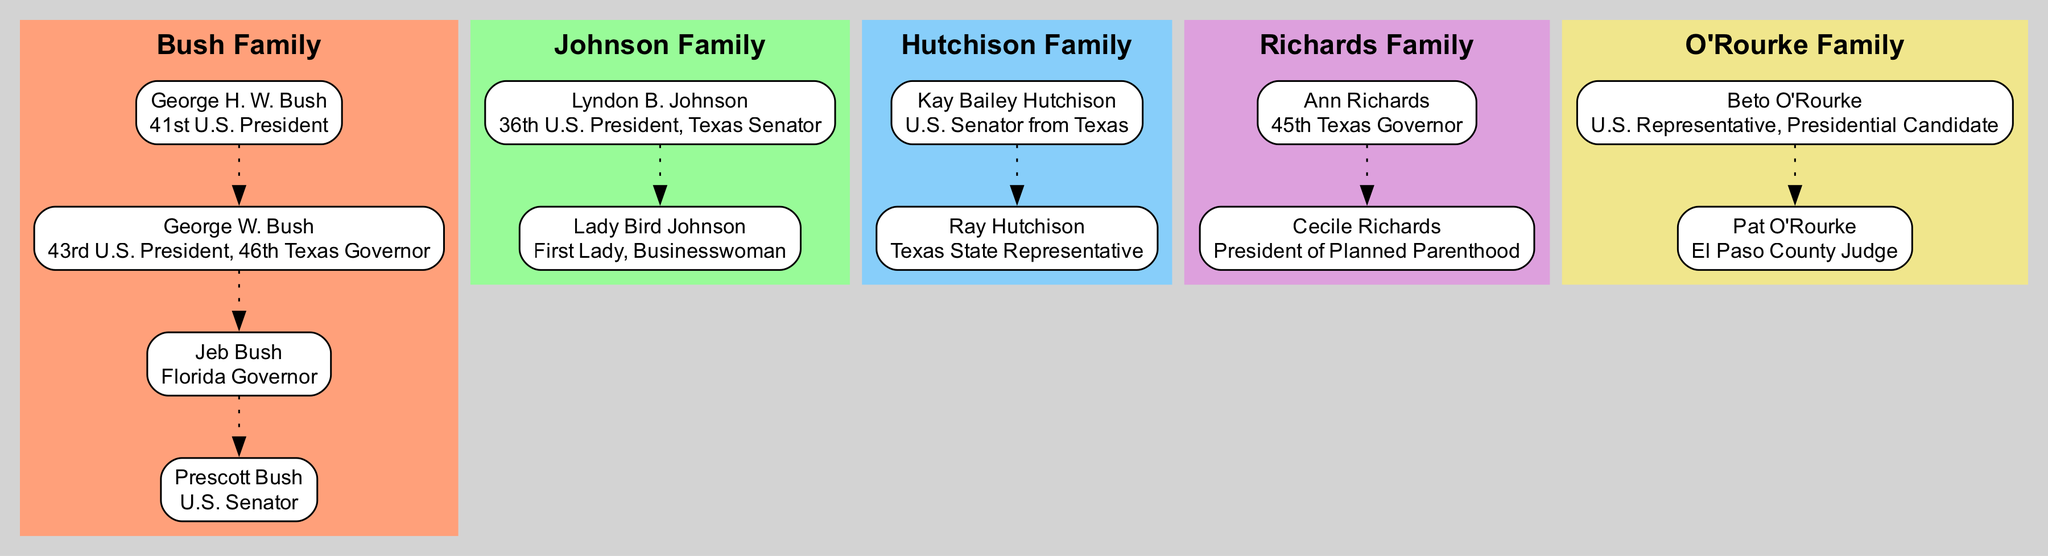What family does George W. Bush belong to? George W. Bush is listed under the "Bush Family" in the diagram. Each family is labeled with their respective notable members, and George W. Bush is clearly shown as a member of this family.
Answer: Bush Family How many family members are in the Johnson Family? The Johnson Family contains two notable members: Lyndon B. Johnson and Lady Bird Johnson. This can be found by counting the nodes connected under the "Johnson Family" label.
Answer: 2 Who is the U.S. Senator from Texas in the Hutchison Family? Kay Bailey Hutchison is identified as the U.S. Senator from Texas in the Hutchison Family section of the diagram. The role is clearly stated next to her name, connecting her directly to the family.
Answer: Kay Bailey Hutchison Which political position does Cecile Richards hold? Cecile Richards is noted as the President of Planned Parenthood. This information is directly displayed under her name in the "Richards Family" section of the diagram.
Answer: President of Planned Parenthood Which family has the most members listed in the diagram? The Bush Family has four notable members listed: George H. W. Bush, George W. Bush, Jeb Bush, and Prescott Bush. Counting the nodes shows this is more than any other family.
Answer: Bush Family Who in the O'Rourke Family is a U.S. Representative? Beto O'Rourke is mentioned as the U.S. Representative in the O'Rourke Family. His title is presented clearly next to his name, providing direct information about his role.
Answer: Beto O'Rourke Which family does Ann Richards represent? Ann Richards is represented under the "Richards Family" in the diagram. Her name is directly linked to that family, and her position as the 45th Texas Governor is included next to it.
Answer: Richards Family What is the total number of families represented in the diagram? There are five distinct families represented in the diagram: Bush, Johnson, Hutchison, Richards, and O'Rourke. Counting these families shows the total.
Answer: 5 Which family member is connected to the Texas State Representative position? Ray Hutchison is identified as the Texas State Representative in the Hutchison Family. His title is shown next to his name, linking him to that specific role.
Answer: Ray Hutchison 